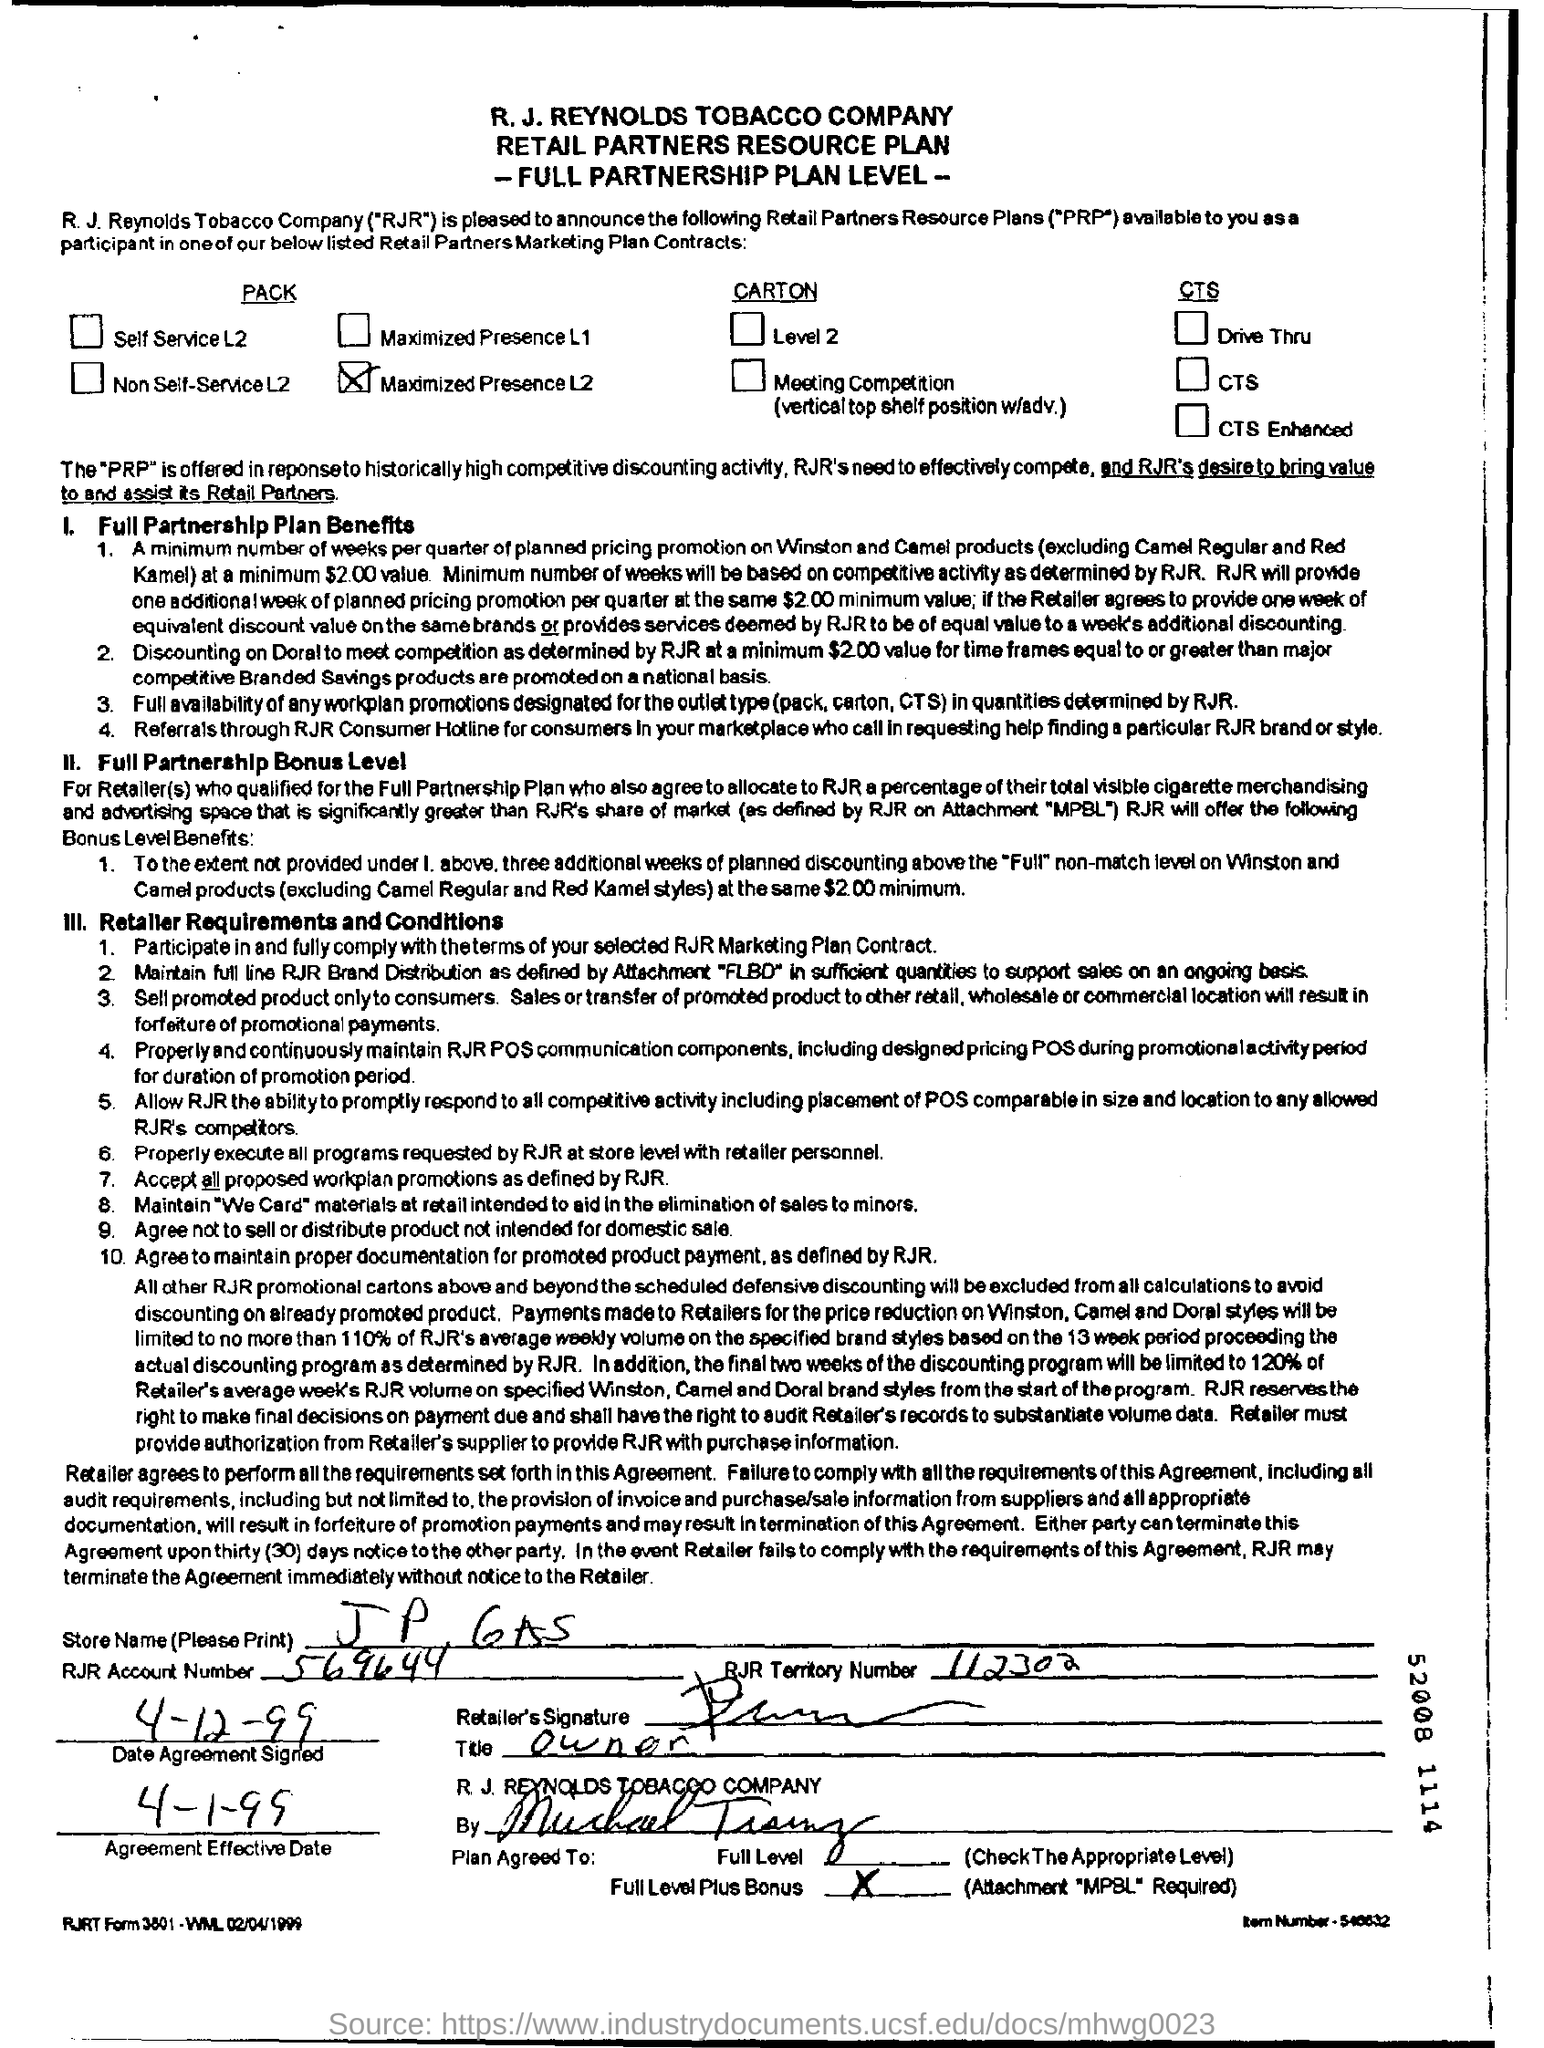Indicate a few pertinent items in this graphic. The Agreement Effective Date is April 1, 1999. The Store Name is J P 6AS. The RJR Territory Number is 112302. The RJR account number given in the form is 569644... The RJR Account Number is 569644... 